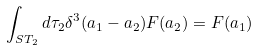<formula> <loc_0><loc_0><loc_500><loc_500>\int _ { S T _ { 2 } } d \tau _ { 2 } \delta ^ { 3 } ( a _ { 1 } - a _ { 2 } ) F ( a _ { 2 } ) = F ( a _ { 1 } )</formula> 